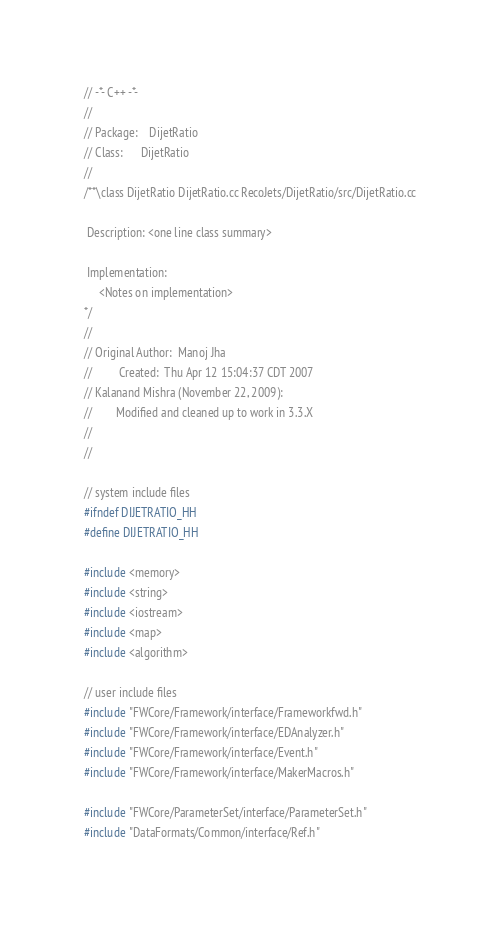<code> <loc_0><loc_0><loc_500><loc_500><_C_>// -*- C++ -*-
//
// Package:    DijetRatio
// Class:      DijetRatio
// 
/**\class DijetRatio DijetRatio.cc RecoJets/DijetRatio/src/DijetRatio.cc

 Description: <one line class summary>

 Implementation:
     <Notes on implementation>
*/
//
// Original Author:  Manoj Jha
//         Created:  Thu Apr 12 15:04:37 CDT 2007
// Kalanand Mishra (November 22, 2009): 
//        Modified and cleaned up to work in 3.3.X
//
//

// system include files
#ifndef DIJETRATIO_HH
#define DIJETRATIO_HH

#include <memory>
#include <string>
#include <iostream>
#include <map>
#include <algorithm>

// user include files
#include "FWCore/Framework/interface/Frameworkfwd.h"
#include "FWCore/Framework/interface/EDAnalyzer.h"
#include "FWCore/Framework/interface/Event.h"
#include "FWCore/Framework/interface/MakerMacros.h"

#include "FWCore/ParameterSet/interface/ParameterSet.h"
#include "DataFormats/Common/interface/Ref.h"</code> 